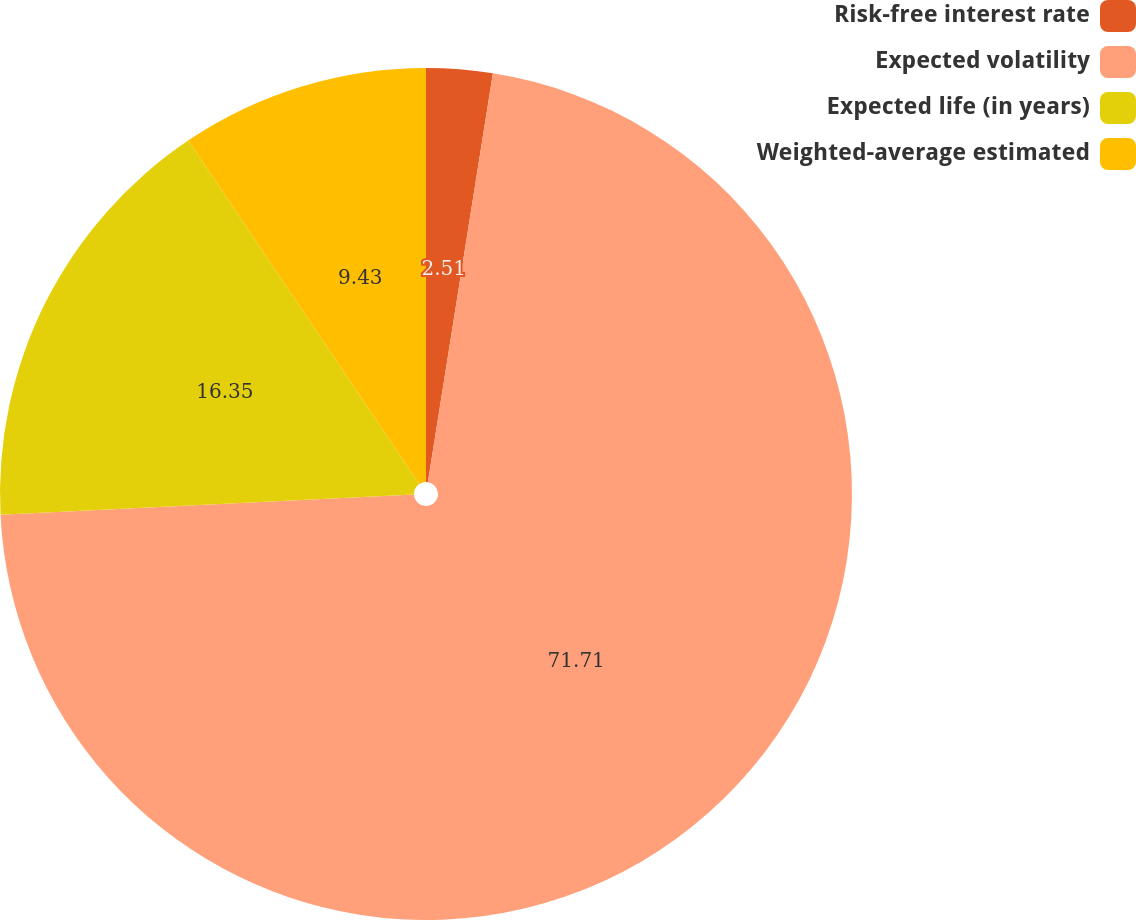Convert chart. <chart><loc_0><loc_0><loc_500><loc_500><pie_chart><fcel>Risk-free interest rate<fcel>Expected volatility<fcel>Expected life (in years)<fcel>Weighted-average estimated<nl><fcel>2.51%<fcel>71.71%<fcel>16.35%<fcel>9.43%<nl></chart> 